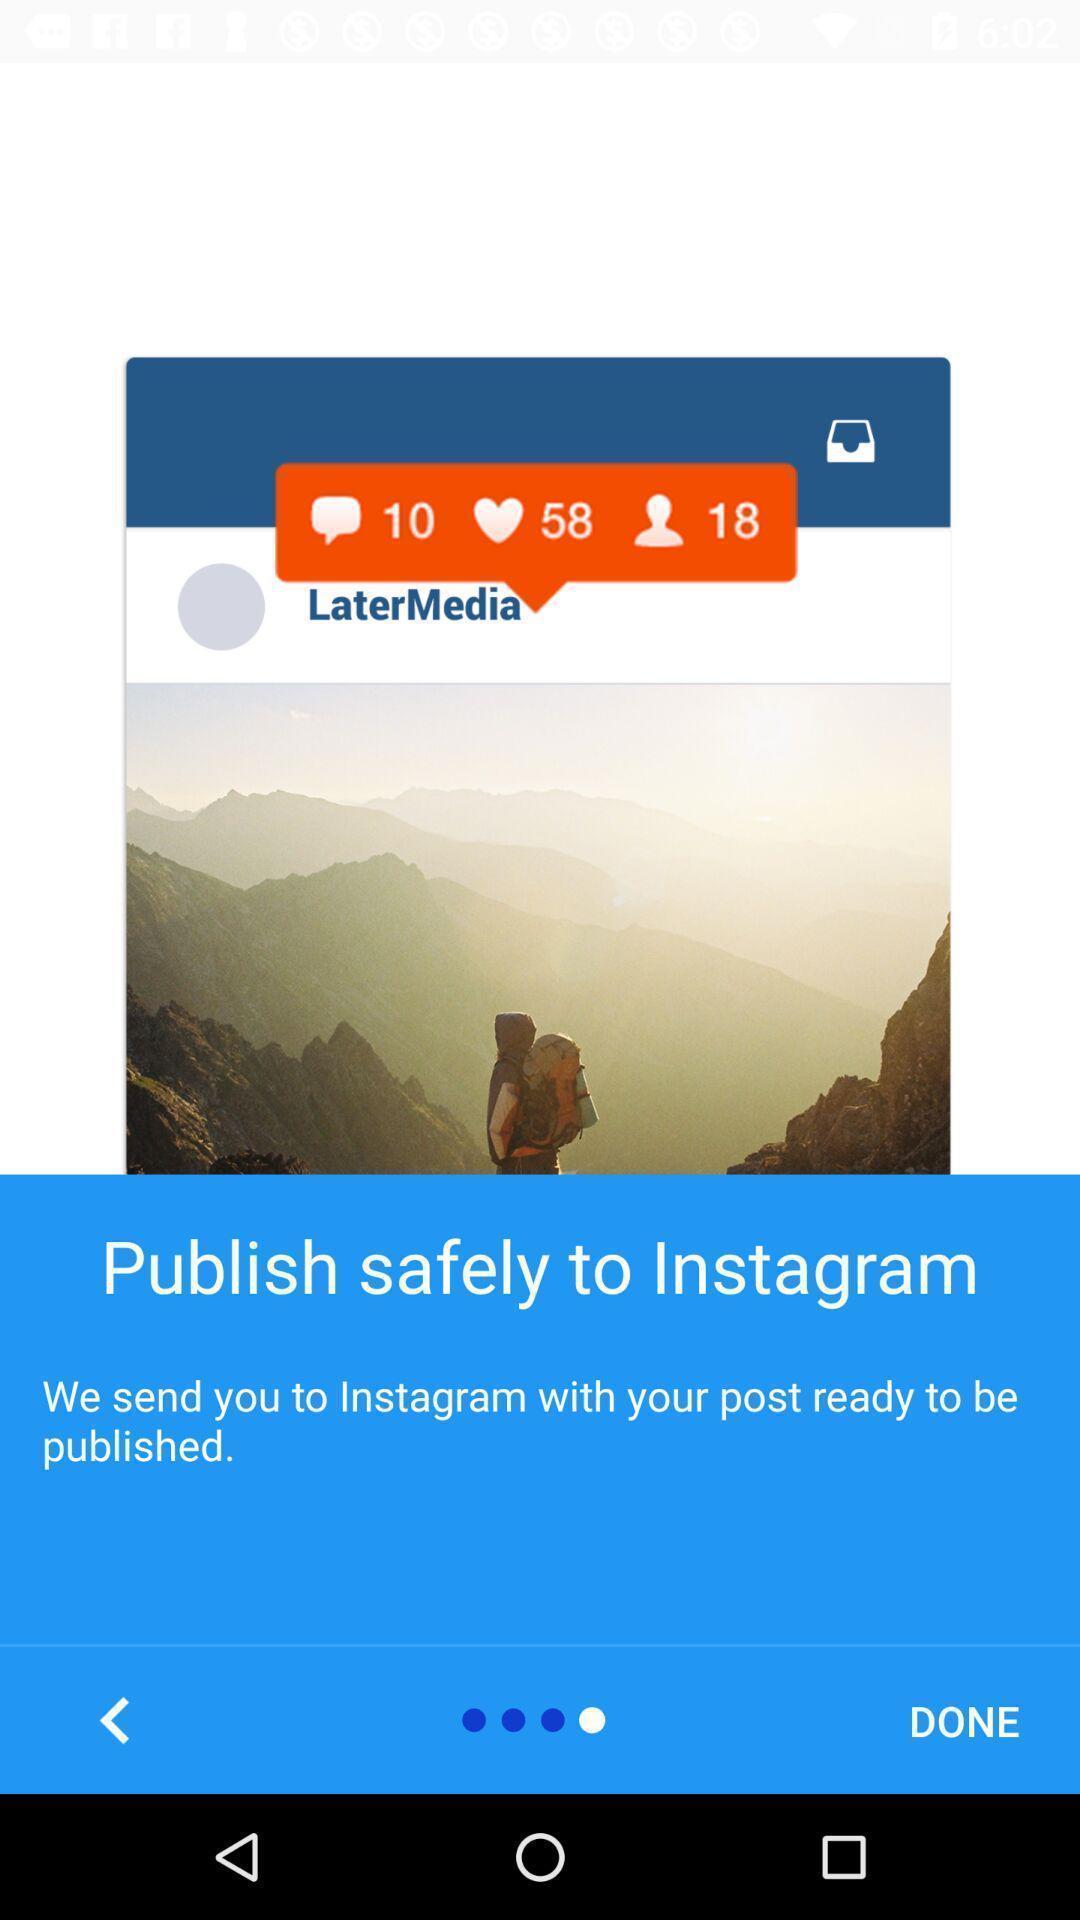What is the overall content of this screenshot? Screen displaying information about a social post. 